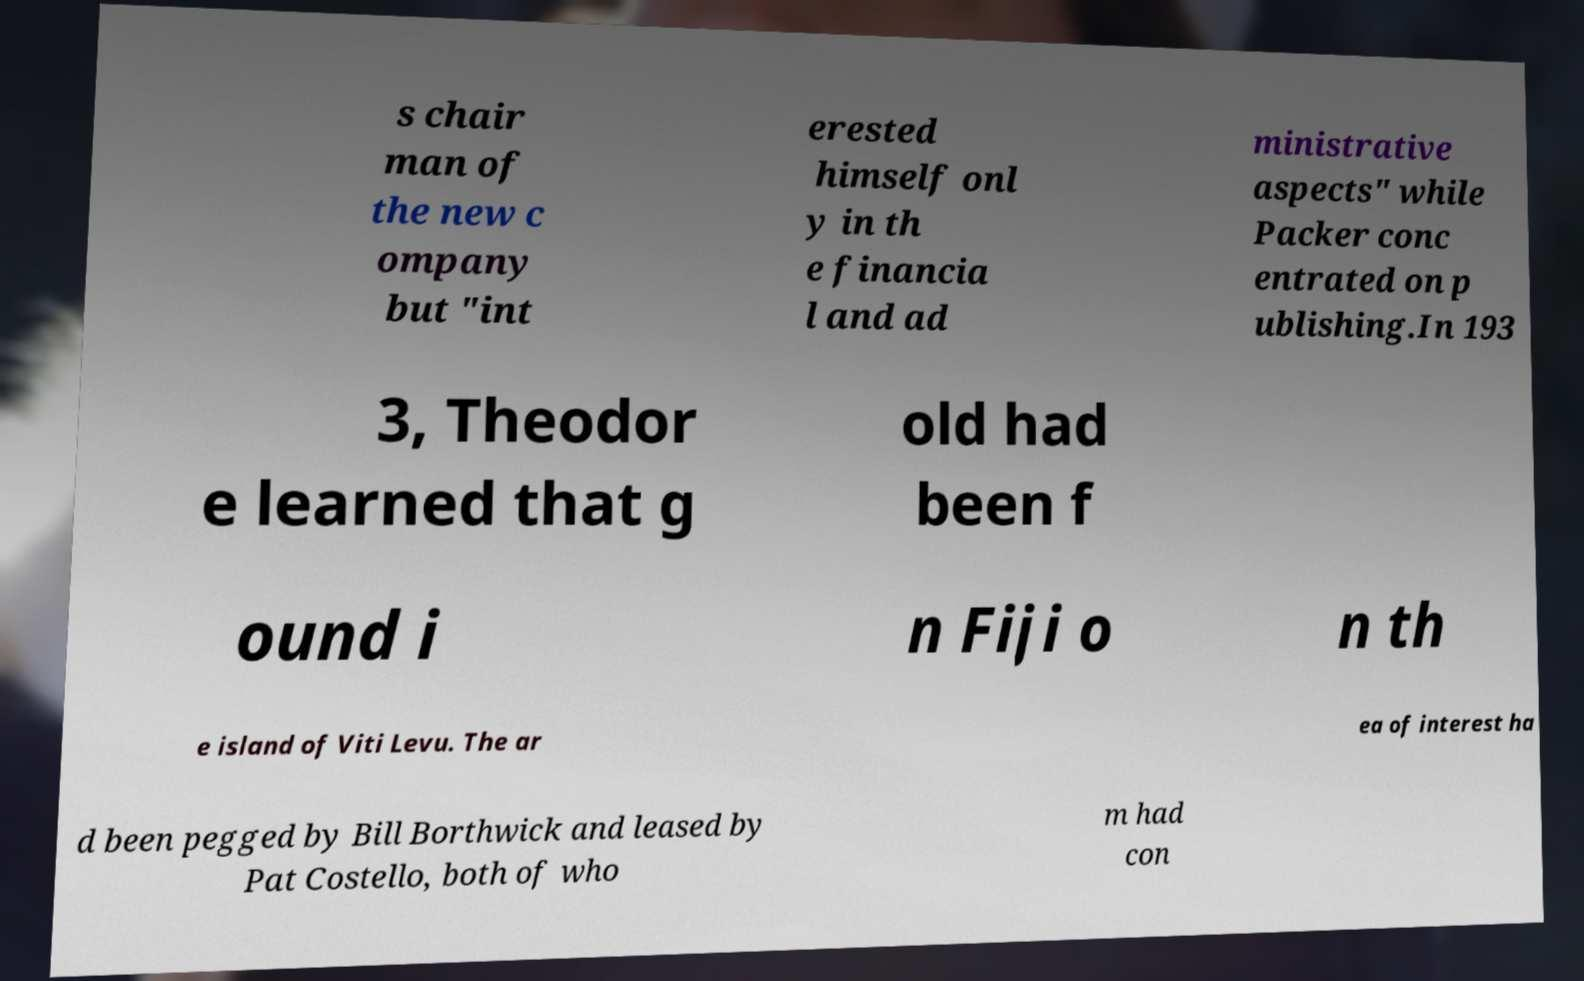Please read and relay the text visible in this image. What does it say? s chair man of the new c ompany but "int erested himself onl y in th e financia l and ad ministrative aspects" while Packer conc entrated on p ublishing.In 193 3, Theodor e learned that g old had been f ound i n Fiji o n th e island of Viti Levu. The ar ea of interest ha d been pegged by Bill Borthwick and leased by Pat Costello, both of who m had con 